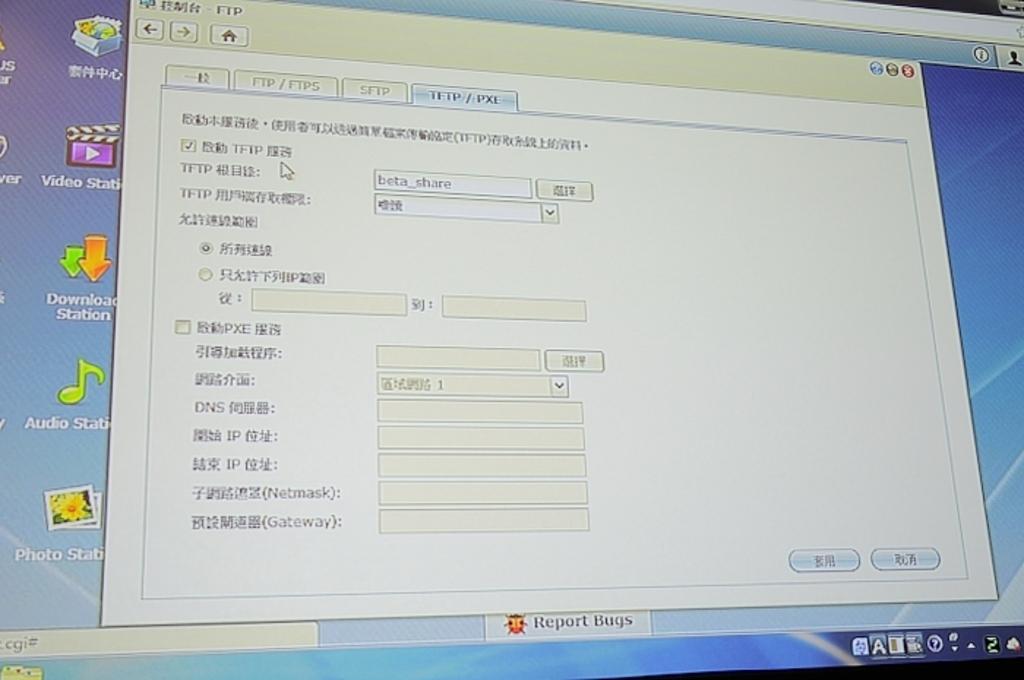What application is minimized?
Provide a succinct answer. Report bugs. Is there a video app in the background?
Keep it short and to the point. Yes. 